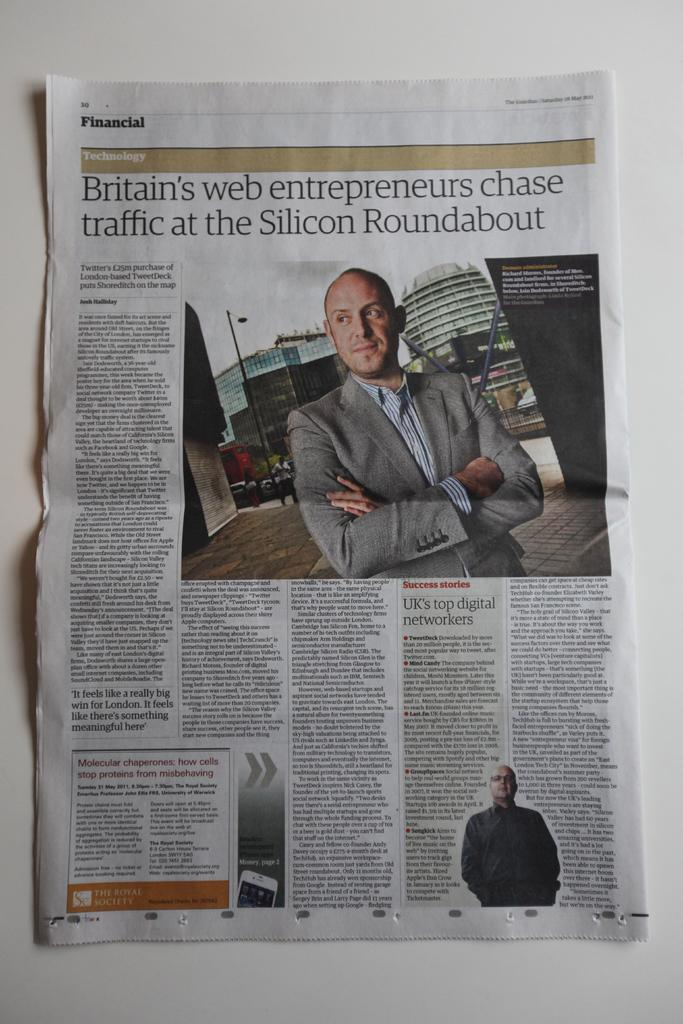Who is present in the image? There is a man in the image. What is the man holding in the image? The man is holding a newspaper. What type of clothing is the man wearing? The man is wearing a coat and a shirt. What can be seen in the background of the image? There are buildings in the background of the image. What type of destruction can be seen in the image? There is no destruction present in the image; it features a man holding a newspaper and buildings in the background. 